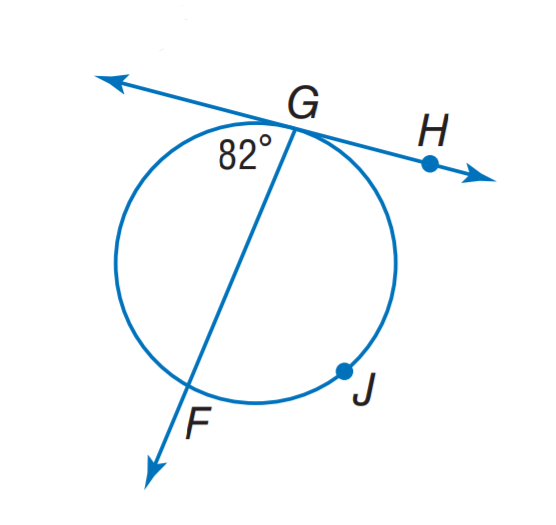Answer the mathemtical geometry problem and directly provide the correct option letter.
Question: Find m \widehat G J F.
Choices: A: 82 B: 164 C: 196 D: 216 C 